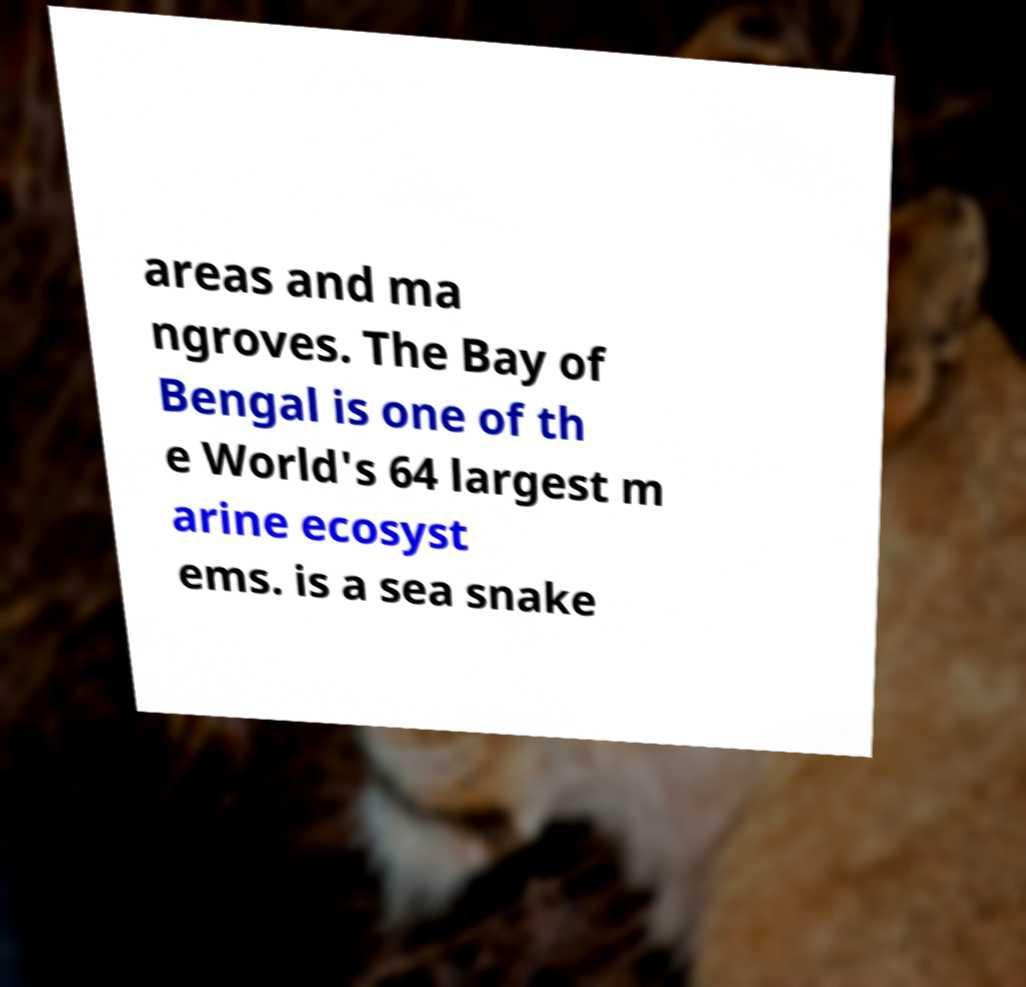What messages or text are displayed in this image? I need them in a readable, typed format. areas and ma ngroves. The Bay of Bengal is one of th e World's 64 largest m arine ecosyst ems. is a sea snake 